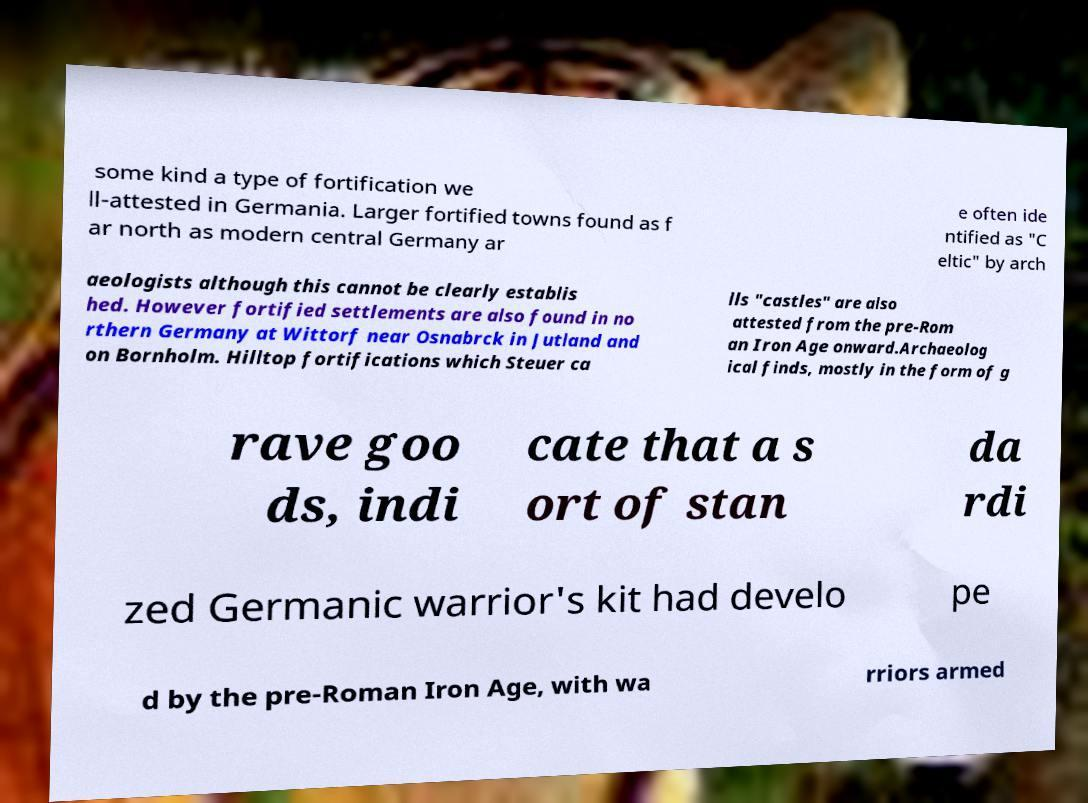I need the written content from this picture converted into text. Can you do that? some kind a type of fortification we ll-attested in Germania. Larger fortified towns found as f ar north as modern central Germany ar e often ide ntified as "C eltic" by arch aeologists although this cannot be clearly establis hed. However fortified settlements are also found in no rthern Germany at Wittorf near Osnabrck in Jutland and on Bornholm. Hilltop fortifications which Steuer ca lls "castles" are also attested from the pre-Rom an Iron Age onward.Archaeolog ical finds, mostly in the form of g rave goo ds, indi cate that a s ort of stan da rdi zed Germanic warrior's kit had develo pe d by the pre-Roman Iron Age, with wa rriors armed 